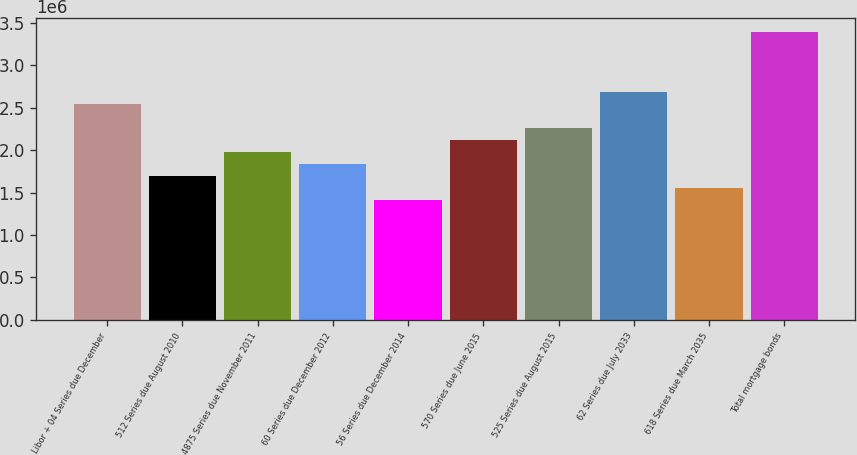<chart> <loc_0><loc_0><loc_500><loc_500><bar_chart><fcel>Libor + 04 Series due December<fcel>512 Series due August 2010<fcel>4875 Series due November 2011<fcel>60 Series due December 2012<fcel>56 Series due December 2014<fcel>570 Series due June 2015<fcel>525 Series due August 2015<fcel>62 Series due July 2033<fcel>618 Series due March 2035<fcel>Total mortgage bonds<nl><fcel>2.54256e+06<fcel>1.69538e+06<fcel>1.97777e+06<fcel>1.83658e+06<fcel>1.41299e+06<fcel>2.11897e+06<fcel>2.26016e+06<fcel>2.68375e+06<fcel>1.55418e+06<fcel>3.38974e+06<nl></chart> 